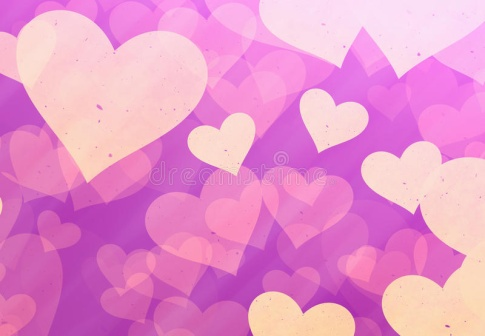Imagine this scene depicts a bustling city. What would be the key elements of this city's culture inspired by this image? In the heart of the bustling city of Amoris, inspired by this dreamlike image, love and creativity are the cornerstones of its vibrant culture. The cityscape is adorned with colorful murals and sculptures of hearts, symbolizing unity and passion. Every year, the residents celebrate the Festival of Hearts, where streets are festooned with heart-shaped lanterns, and artists showcase their masterpieces representing various facets of love. In the central plaza, a mesmerizing fountain with heart-shaped jets sprays water that sparkles under the sun, becoming a popular gathering spot for couples and families. Cafes and patisseries brim with heart-themed delicacies, reflecting the city's culinary love affair. Music, poetry, and dance flourish here, with love songs and heartfelt performances at open-air theaters and parks, reinforcing Amoris' reputation as the city where love and art intertwine seamlessly. How would people in Amoris celebrate their relationships? In Amoris, relationships are celebrated with grand gestures and intimate moments alike. Couples exchange intricately designed heart tokens engraved with personal vows during the annual Heart Exchange ceremony. Families partake in Love Feasts, where traditional recipes passed down generations are shared, fostering a deep sense of belonging. Friends embark on Heart Quests, adventures throughout the city that lead to landmarks symbolizing different kinds of love, strengthening their bonds. Additionally, the Heartkeeper's Blessing, a serene ceremony at the revered Heart Fountain, is a cherished tradition where people renew their commitments under cascading sparkles of water, believed to bless their relationships with enduring love and harmony. 